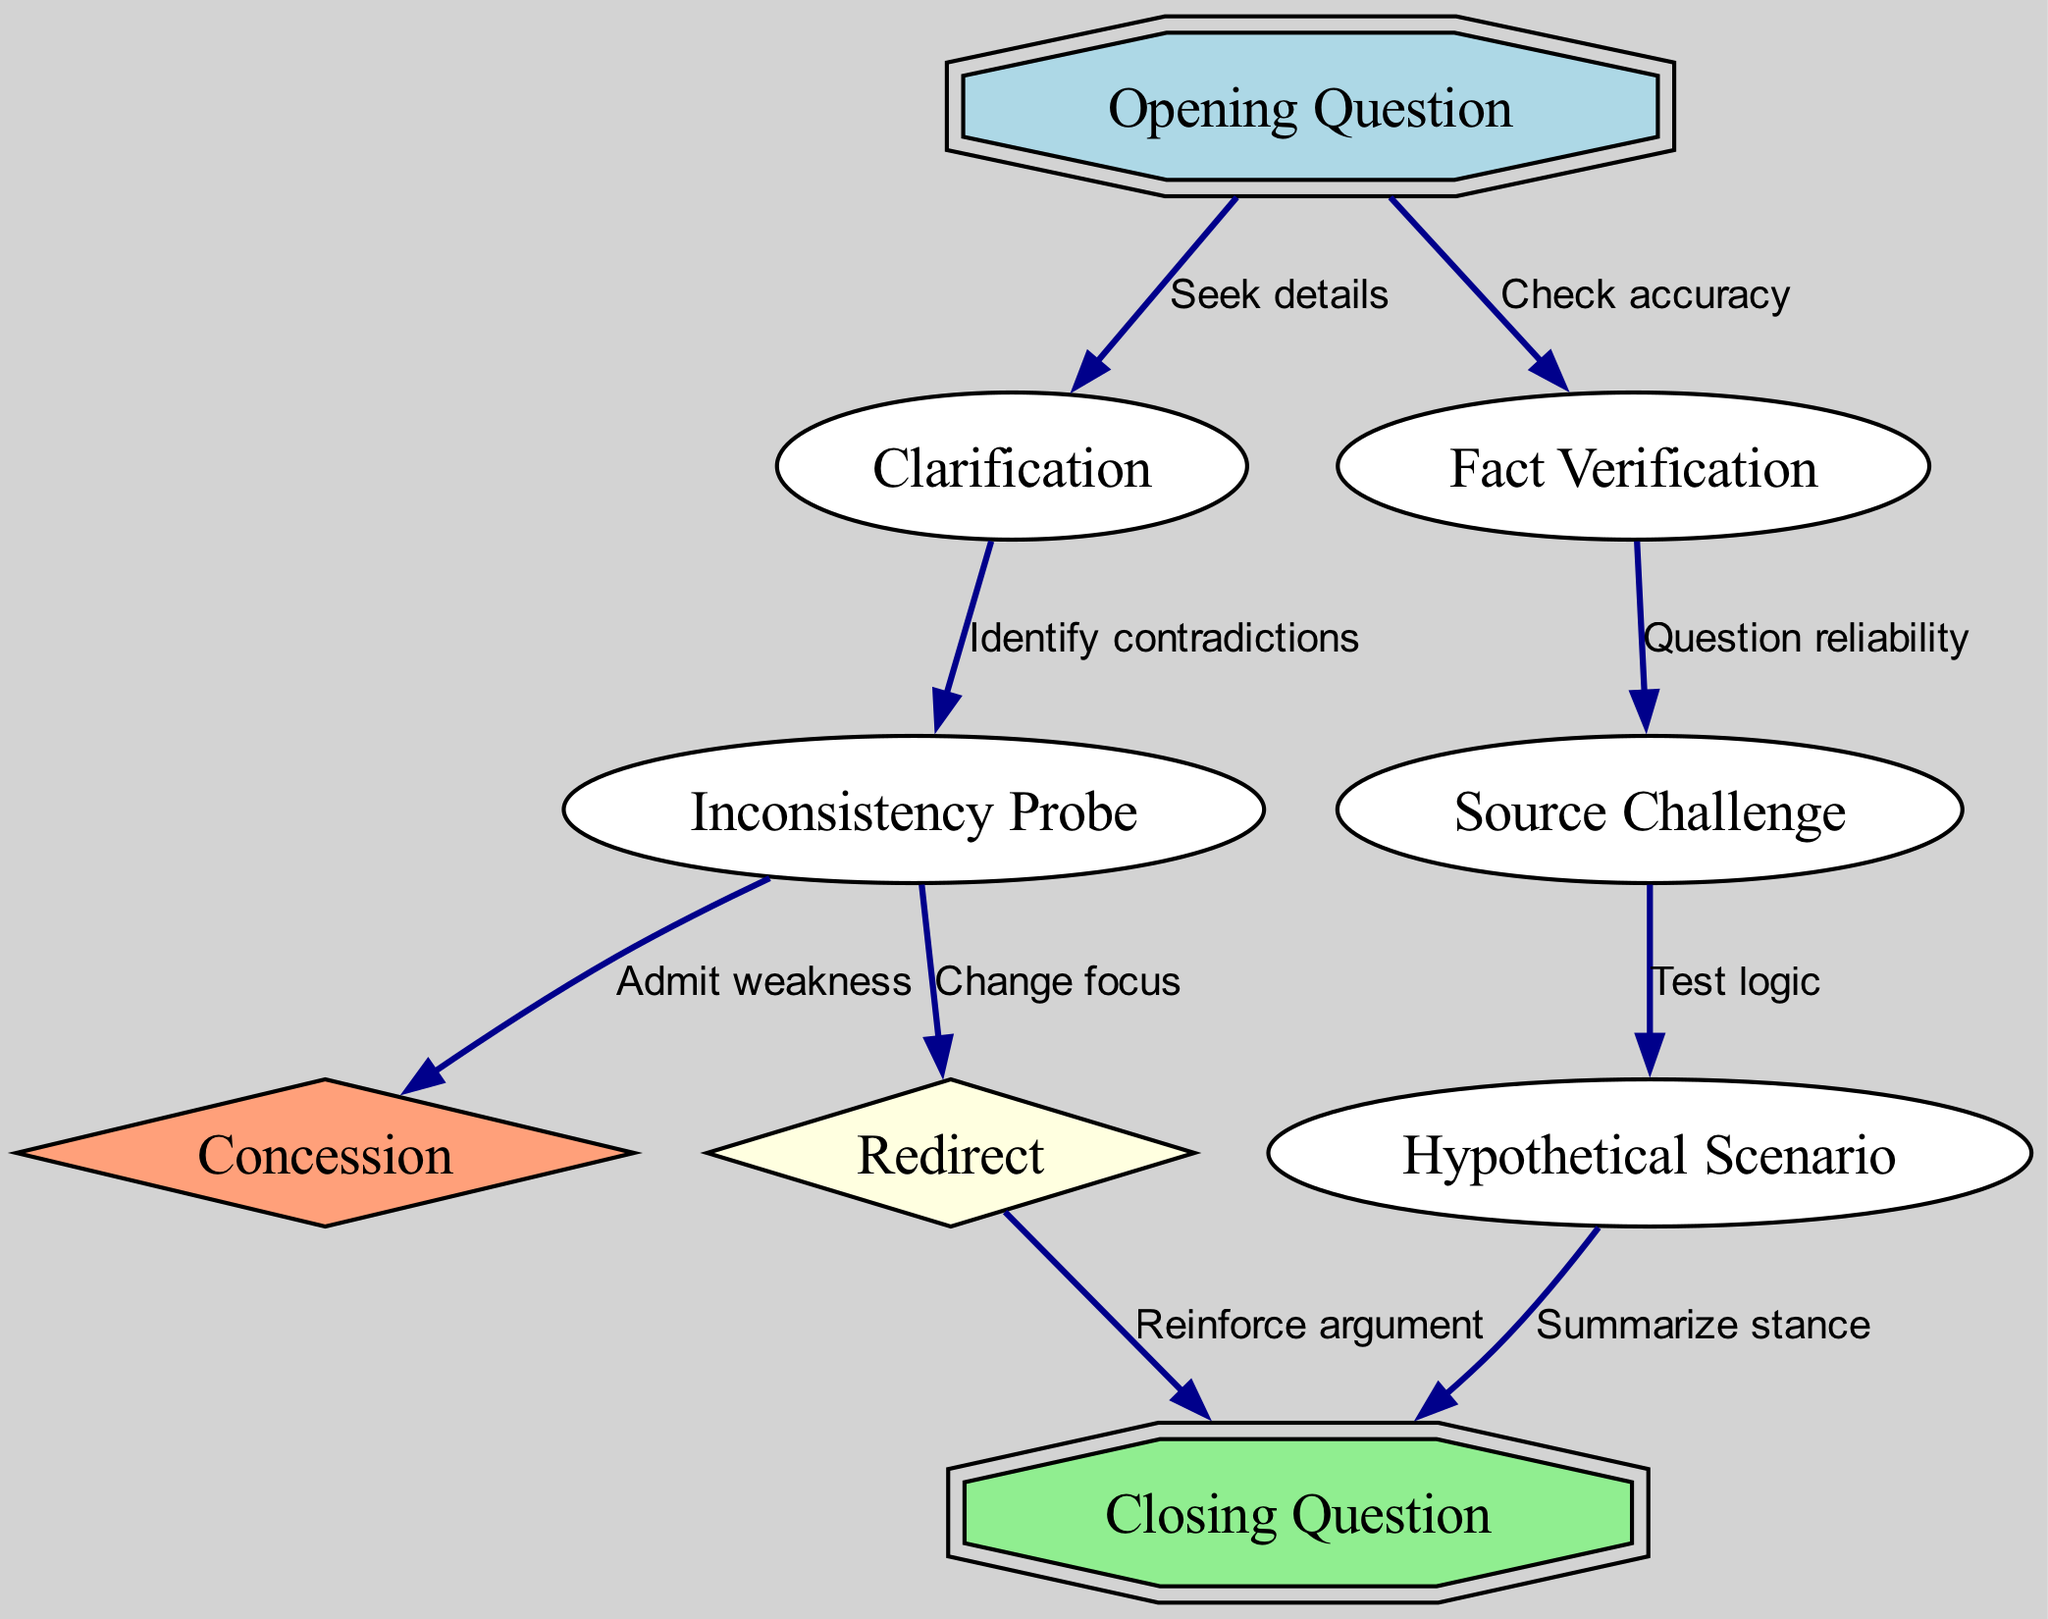What is the total number of nodes in the diagram? The diagram includes a list of nodes that can be counted directly. There are 8 nodes listed in the data: "Opening Question," "Clarification," "Fact Verification," "Inconsistency Probe," "Source Challenge," "Hypothetical Scenario," "Concession," and "Redirect." Hence, the total count is 8.
Answer: 8 Which node is connected to "Fact Verification"? By examining the edges listed, we see that "Fact Verification" has one outgoing edge leading to "Source Challenge." Therefore, the node directly connected to "Fact Verification" is "Source Challenge."
Answer: Source Challenge What type of question follows "Hypothetical Scenario"? Looking at the direction of the arrows in the edges, we can see that the node following "Hypothetical Scenario" is "Closing Question." This indicates the direct progression of questioning strategies stemming from the hypothetical scenario.
Answer: Closing Question How many edges originate from "Inconsistency Probe"? Counting the edges that start from "Inconsistency Probe," we see two outgoing connections: one to "Concession" and another to "Redirect." Thus, the number of edges that originate from "Inconsistency Probe" is 2.
Answer: 2 If a response indicates a concession, which question might follow? Tracing the flow from "Inconsistency Probe," if a concession is admitted, the next logical step in questioning would be to redirect or ask a closing question. However, based on the structure, the immediate follow-up could lead to "Concession." Thus, the likely follow-up question would come from "Inconsistency Probe" leading directly to "Concession."
Answer: Concession What is the relationship established between "Opening Question" and "Fact Verification"? The edge that connects "Opening Question" to "Fact Verification" is labeled "Check accuracy," indicating that the relationship is about verifying the facts after initiating the questioning process. The flow demonstrates that the opening question can lead to a need for verification.
Answer: Check accuracy 